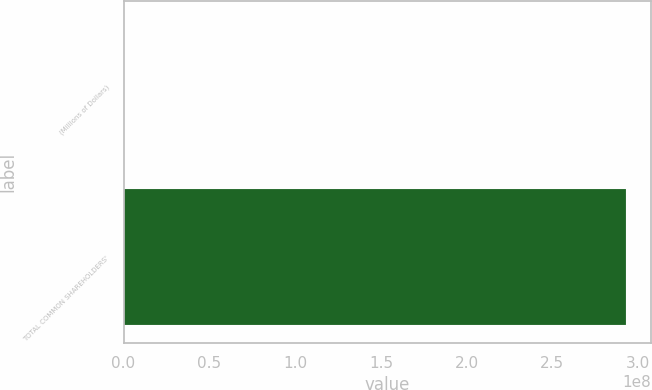Convert chart. <chart><loc_0><loc_0><loc_500><loc_500><bar_chart><fcel>(Millions of Dollars)<fcel>TOTAL COMMON SHAREHOLDERS'<nl><fcel>2012<fcel>2.92872e+08<nl></chart> 